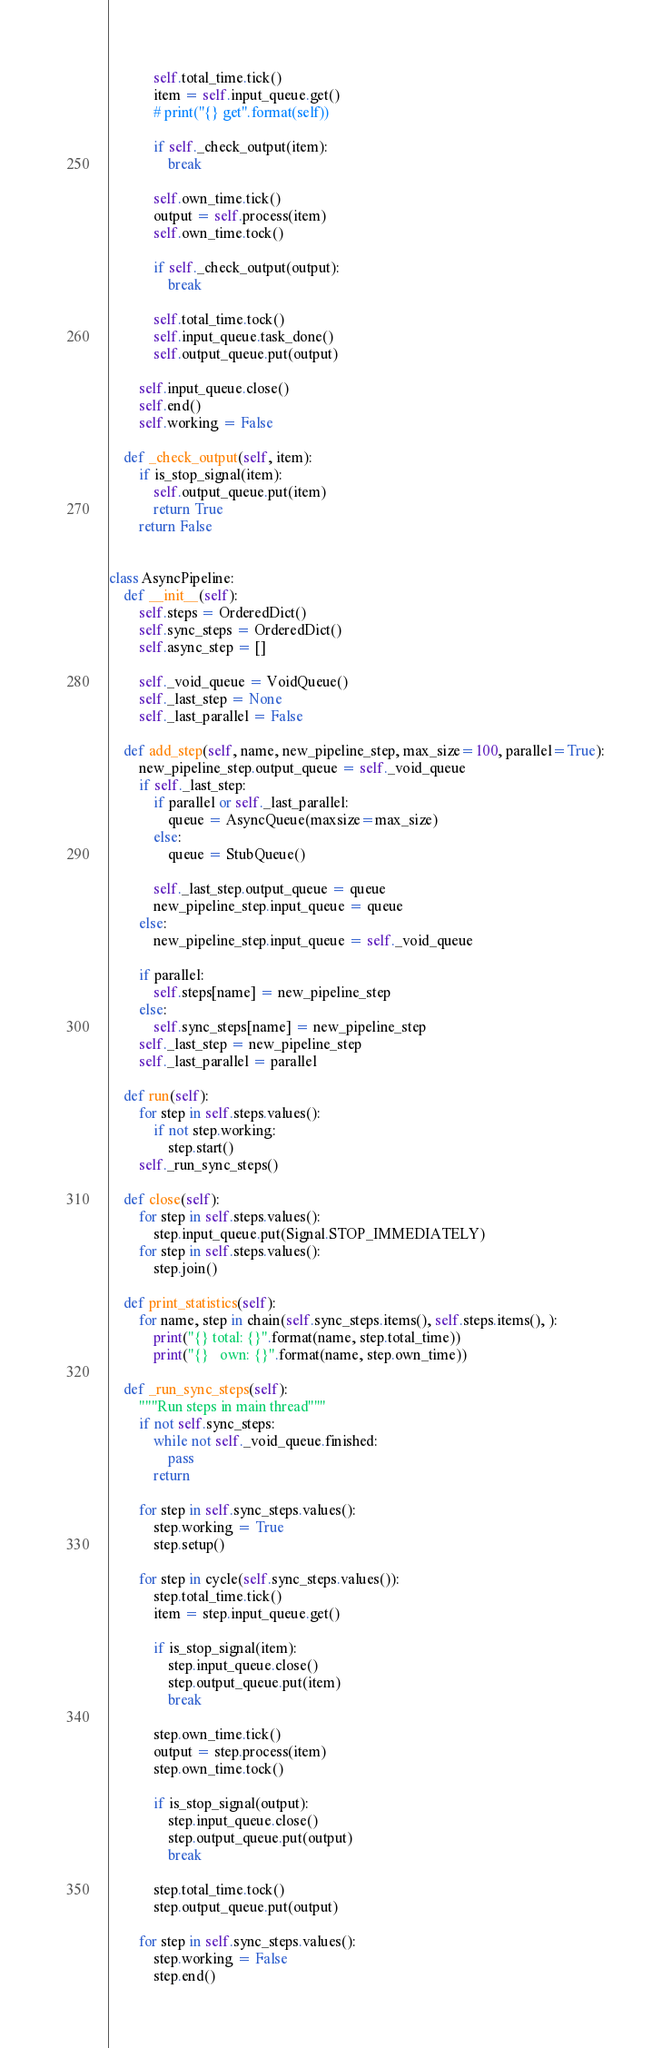<code> <loc_0><loc_0><loc_500><loc_500><_Python_>            self.total_time.tick()
            item = self.input_queue.get()
            # print("{} get".format(self))

            if self._check_output(item):
                break

            self.own_time.tick()
            output = self.process(item)
            self.own_time.tock()

            if self._check_output(output):
                break

            self.total_time.tock()
            self.input_queue.task_done()
            self.output_queue.put(output)

        self.input_queue.close()
        self.end()
        self.working = False

    def _check_output(self, item):
        if is_stop_signal(item):
            self.output_queue.put(item)
            return True
        return False


class AsyncPipeline:
    def __init__(self):
        self.steps = OrderedDict()
        self.sync_steps = OrderedDict()
        self.async_step = []

        self._void_queue = VoidQueue()
        self._last_step = None
        self._last_parallel = False

    def add_step(self, name, new_pipeline_step, max_size=100, parallel=True):
        new_pipeline_step.output_queue = self._void_queue
        if self._last_step:
            if parallel or self._last_parallel:
                queue = AsyncQueue(maxsize=max_size)
            else:
                queue = StubQueue()

            self._last_step.output_queue = queue
            new_pipeline_step.input_queue = queue
        else:
            new_pipeline_step.input_queue = self._void_queue

        if parallel:
            self.steps[name] = new_pipeline_step
        else:
            self.sync_steps[name] = new_pipeline_step
        self._last_step = new_pipeline_step
        self._last_parallel = parallel

    def run(self):
        for step in self.steps.values():
            if not step.working:
                step.start()
        self._run_sync_steps()

    def close(self):
        for step in self.steps.values():
            step.input_queue.put(Signal.STOP_IMMEDIATELY)
        for step in self.steps.values():
            step.join()

    def print_statistics(self):
        for name, step in chain(self.sync_steps.items(), self.steps.items(), ):
            print("{} total: {}".format(name, step.total_time))
            print("{}   own: {}".format(name, step.own_time))

    def _run_sync_steps(self):
        """Run steps in main thread"""
        if not self.sync_steps:
            while not self._void_queue.finished:
                pass
            return

        for step in self.sync_steps.values():
            step.working = True
            step.setup()

        for step in cycle(self.sync_steps.values()):
            step.total_time.tick()
            item = step.input_queue.get()

            if is_stop_signal(item):
                step.input_queue.close()
                step.output_queue.put(item)
                break

            step.own_time.tick()
            output = step.process(item)
            step.own_time.tock()

            if is_stop_signal(output):
                step.input_queue.close()
                step.output_queue.put(output)
                break

            step.total_time.tock()
            step.output_queue.put(output)

        for step in self.sync_steps.values():
            step.working = False
            step.end()
</code> 